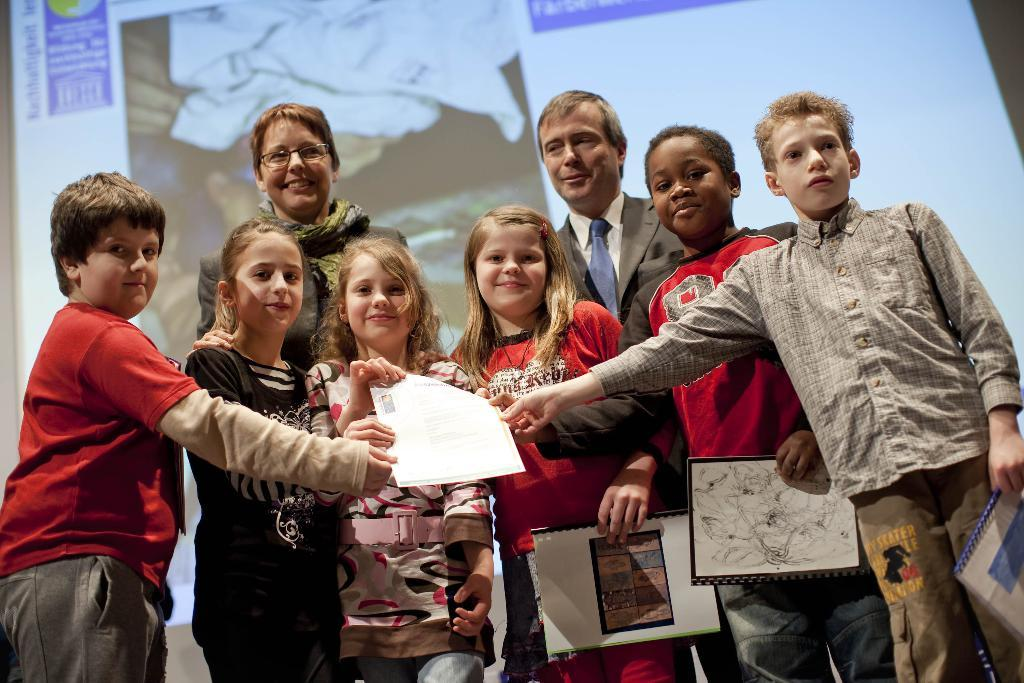What is happening in the image? There are people standing in the image, including kids. What are the kids holding? The kids are holding a paper. What can be seen in the background of the image? There is a screen visible in the background. What type of cabbage is being used as a prop in the image? There is no cabbage present in the image. What activity are the kids participating in the image? The image does not show the kids participating in any specific activity, only holding a paper. 